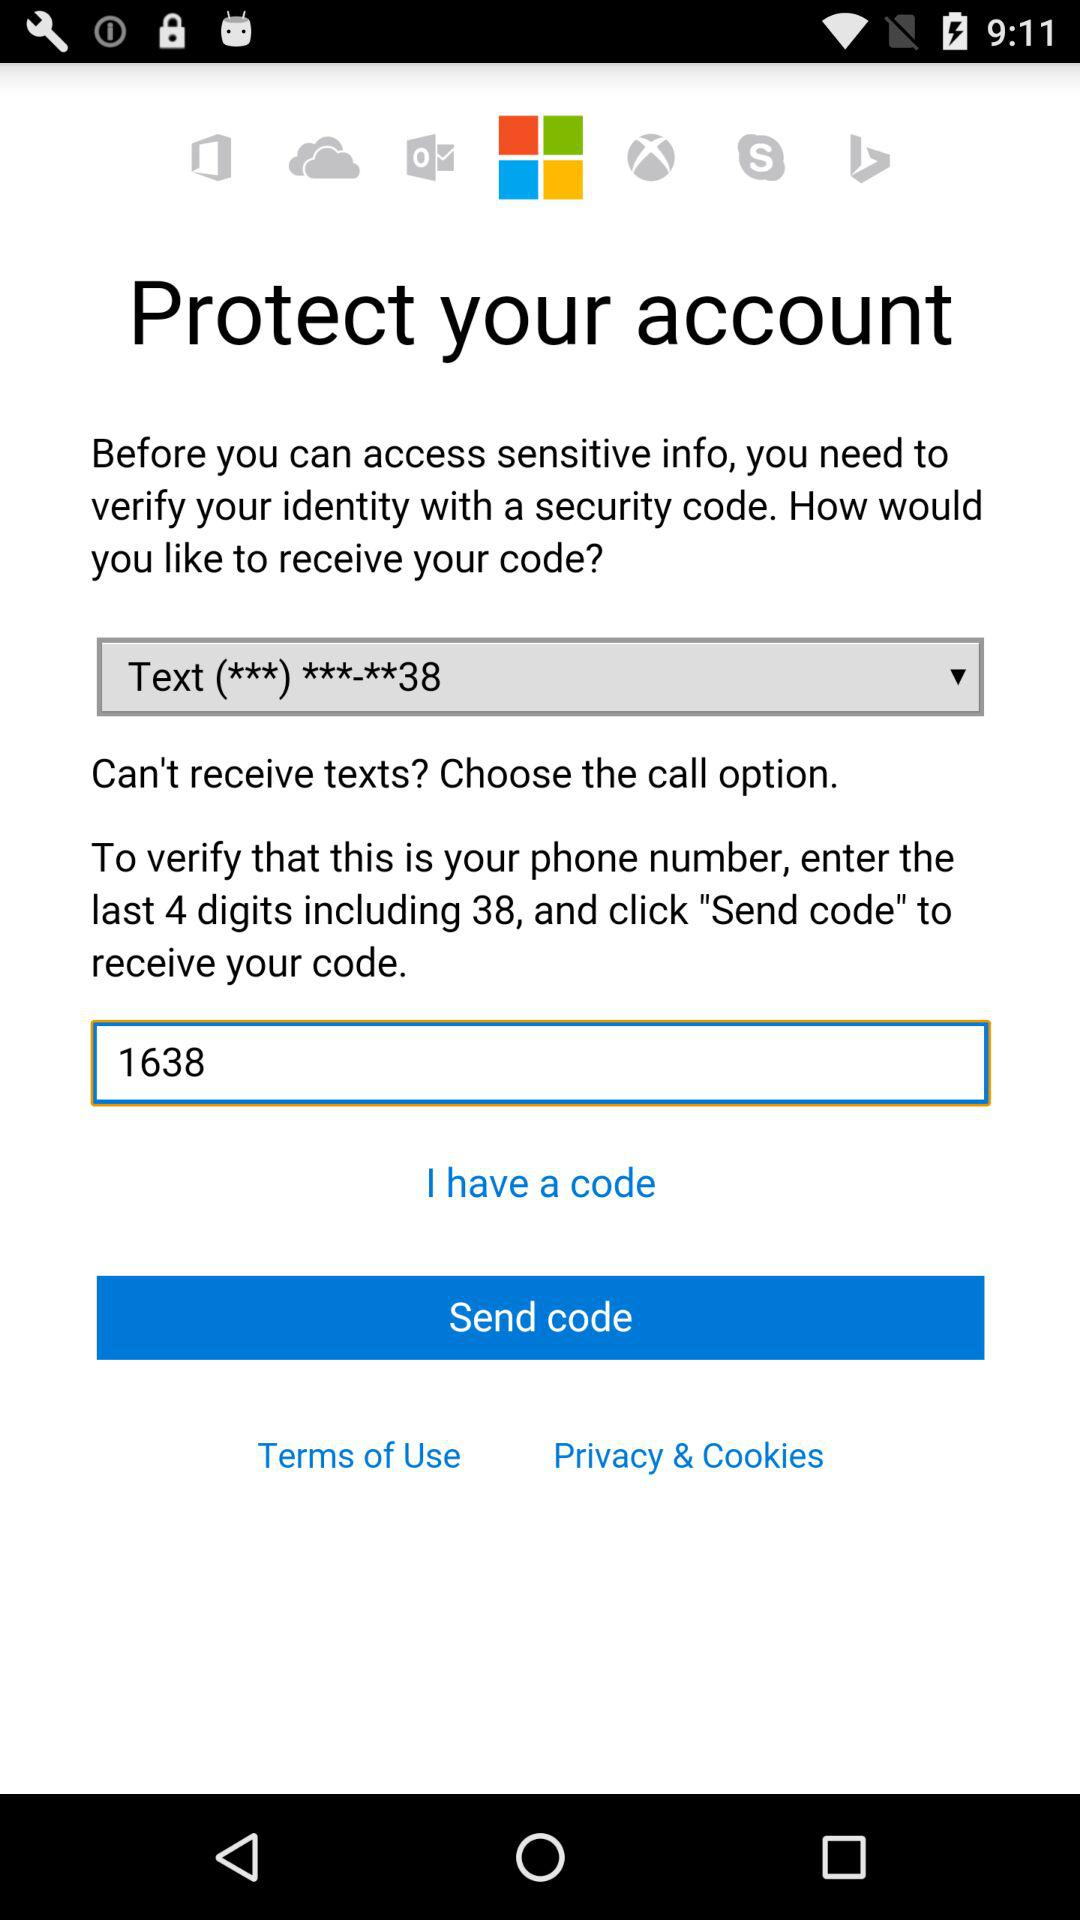What's the 4-digit number typed to verify the phone number to receive the code? The 4-digit number typed to verify the phone number to receive the code is "1638". 